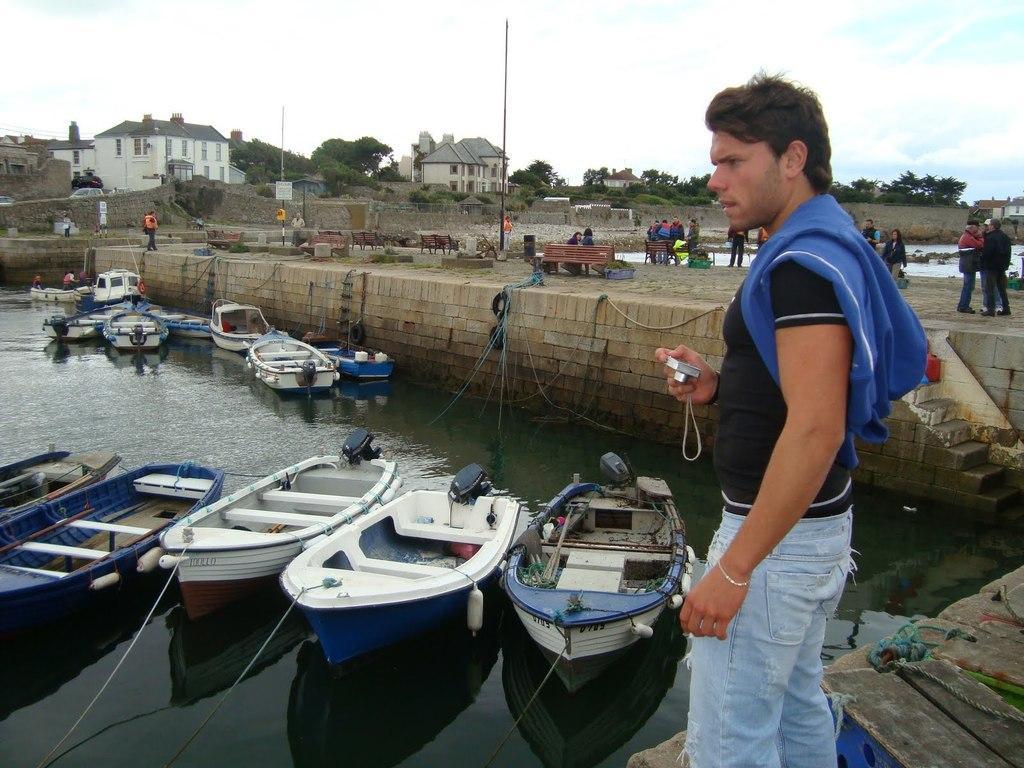Describe this image in one or two sentences. In this image we can see a person holding a camera. There is water. On the water there are many boats. And the boats are tied with ropes. And there is a wall with steps. There are many people. And there are benches. In the background there are buildings with windows. Also there are trees. And there is sky with clouds. 